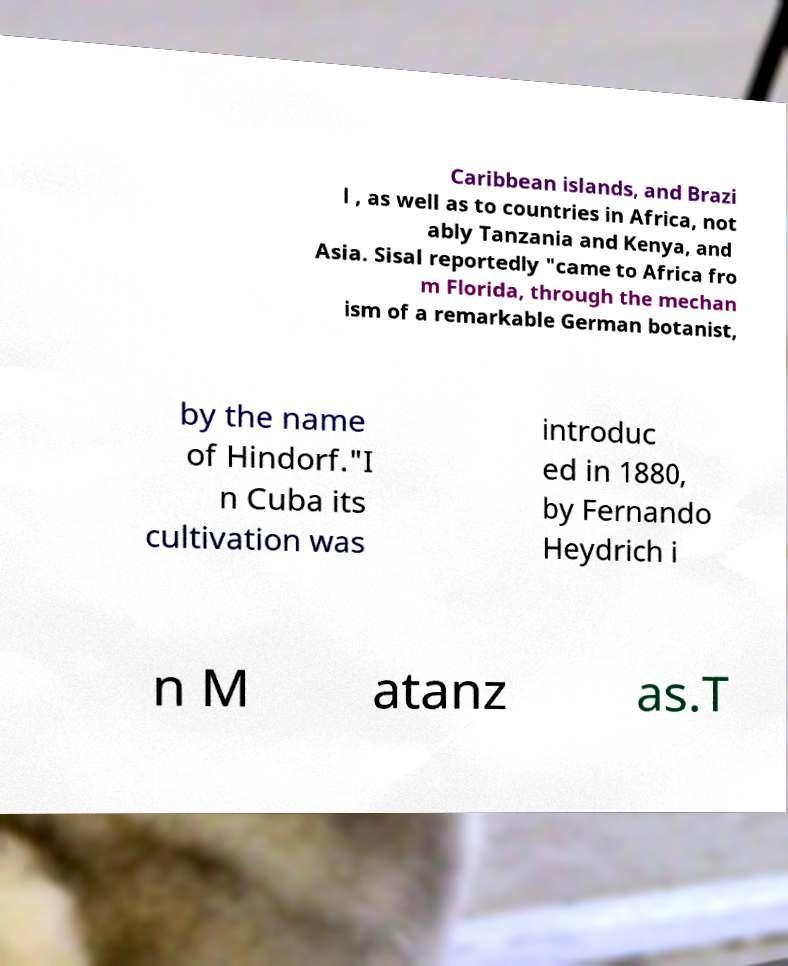Could you assist in decoding the text presented in this image and type it out clearly? Caribbean islands, and Brazi l , as well as to countries in Africa, not ably Tanzania and Kenya, and Asia. Sisal reportedly "came to Africa fro m Florida, through the mechan ism of a remarkable German botanist, by the name of Hindorf."I n Cuba its cultivation was introduc ed in 1880, by Fernando Heydrich i n M atanz as.T 